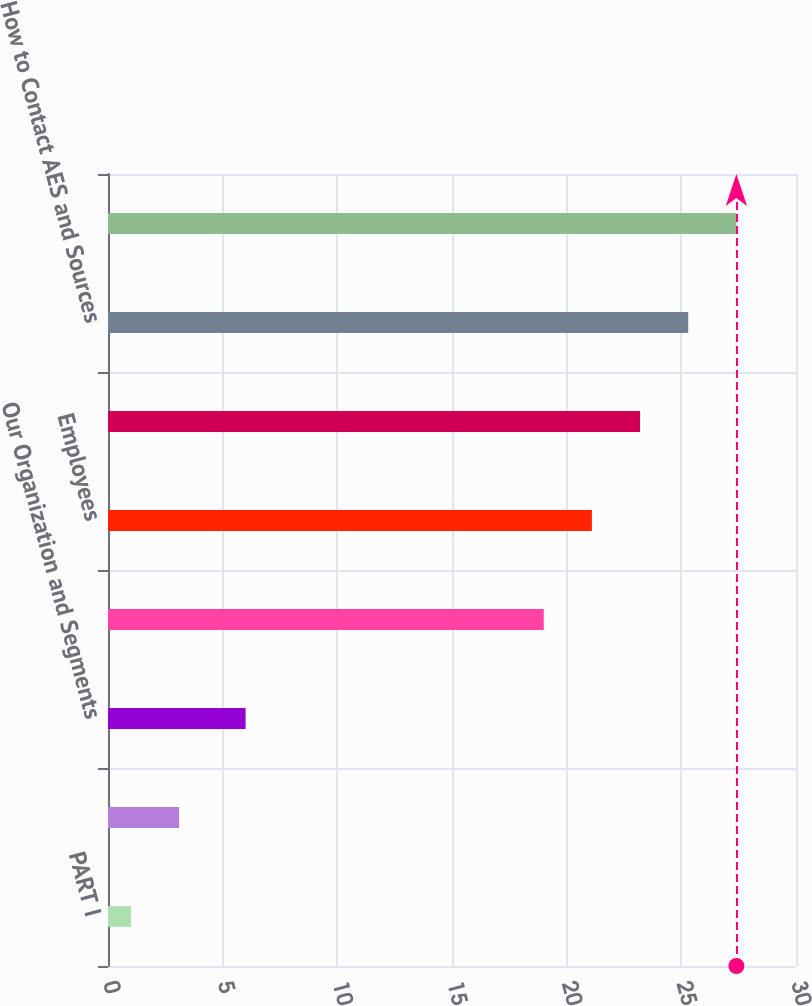Convert chart. <chart><loc_0><loc_0><loc_500><loc_500><bar_chart><fcel>PART I<fcel>Overview<fcel>Our Organization and Segments<fcel>Customers<fcel>Employees<fcel>Executive Officers<fcel>How to Contact AES and Sources<fcel>Regulatory Matters<nl><fcel>1<fcel>3.1<fcel>6<fcel>19<fcel>21.1<fcel>23.2<fcel>25.3<fcel>27.4<nl></chart> 